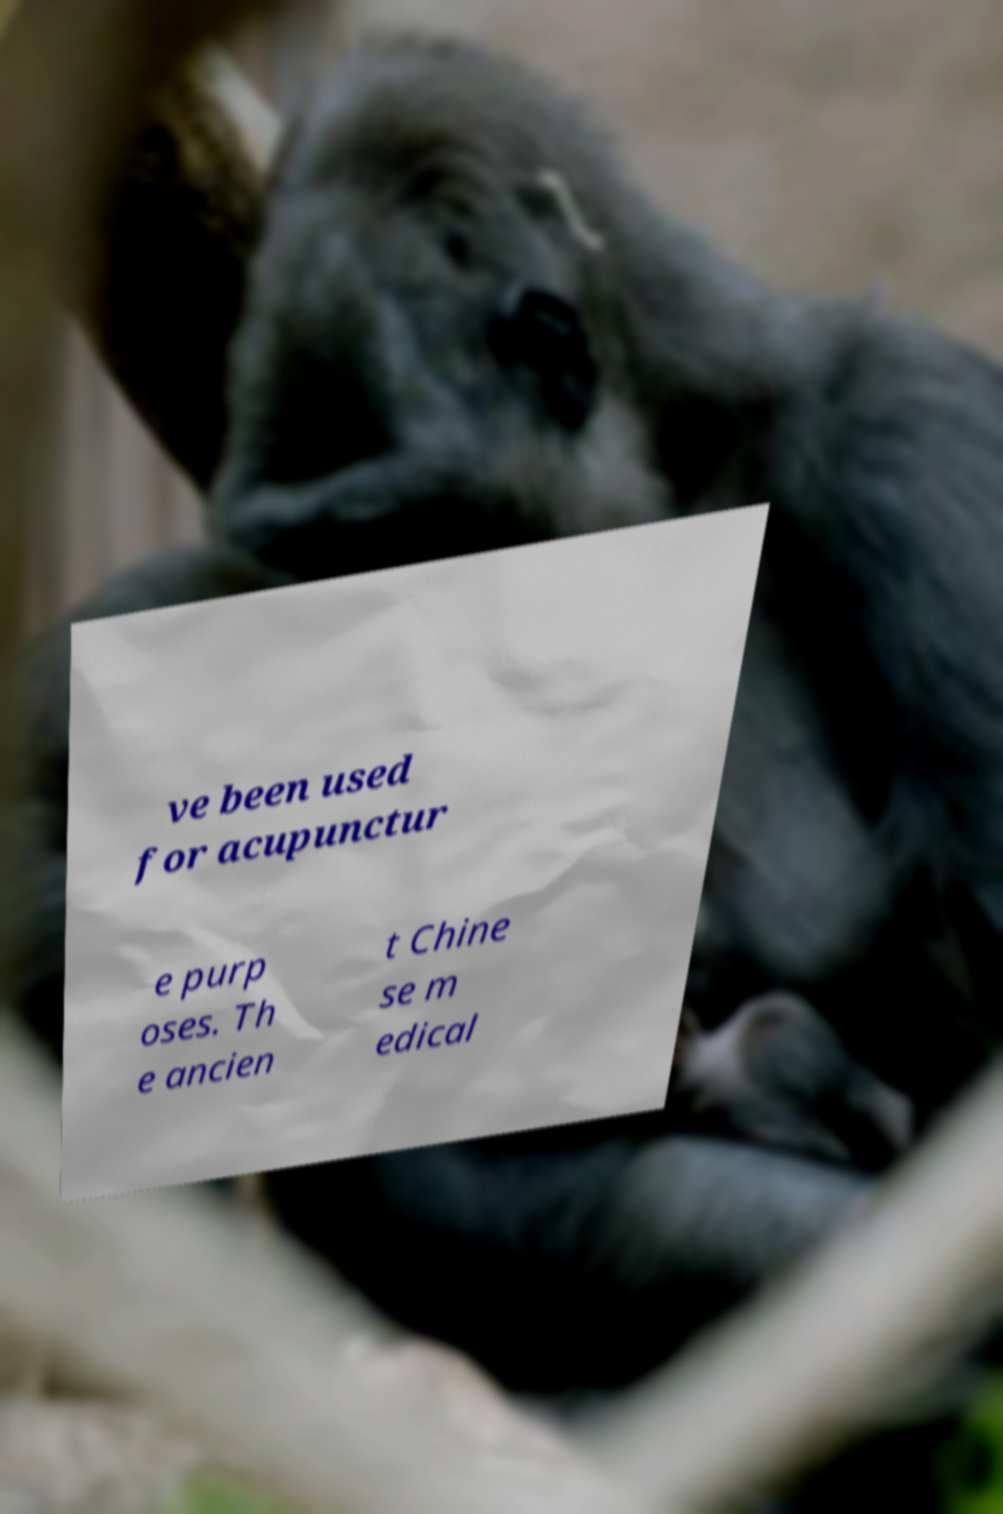Please identify and transcribe the text found in this image. ve been used for acupunctur e purp oses. Th e ancien t Chine se m edical 